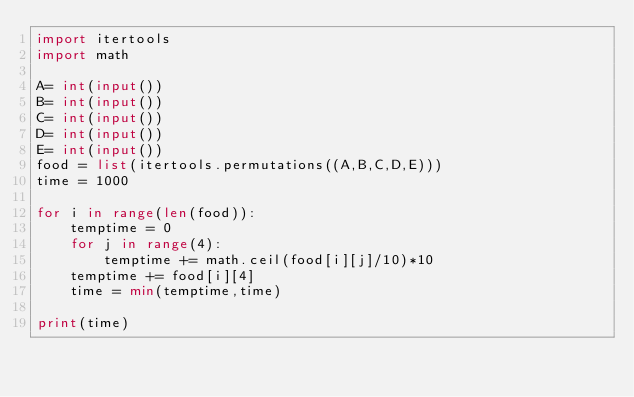Convert code to text. <code><loc_0><loc_0><loc_500><loc_500><_Python_>import itertools
import math

A= int(input())
B= int(input())
C= int(input())
D= int(input())
E= int(input())
food = list(itertools.permutations((A,B,C,D,E)))
time = 1000

for i in range(len(food)):
    temptime = 0
    for j in range(4):
        temptime += math.ceil(food[i][j]/10)*10
    temptime += food[i][4]
    time = min(temptime,time)

print(time)</code> 